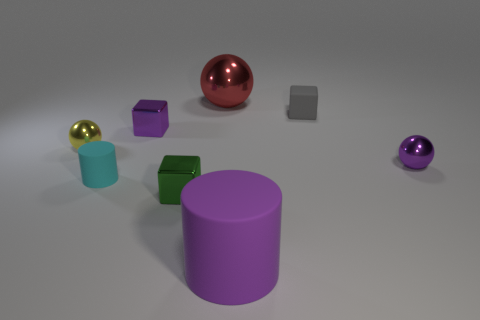Add 1 large green cylinders. How many objects exist? 9 Subtract all cylinders. How many objects are left? 6 Add 8 small gray matte blocks. How many small gray matte blocks are left? 9 Add 4 small yellow rubber blocks. How many small yellow rubber blocks exist? 4 Subtract 0 cyan balls. How many objects are left? 8 Subtract all small gray cubes. Subtract all tiny purple spheres. How many objects are left? 6 